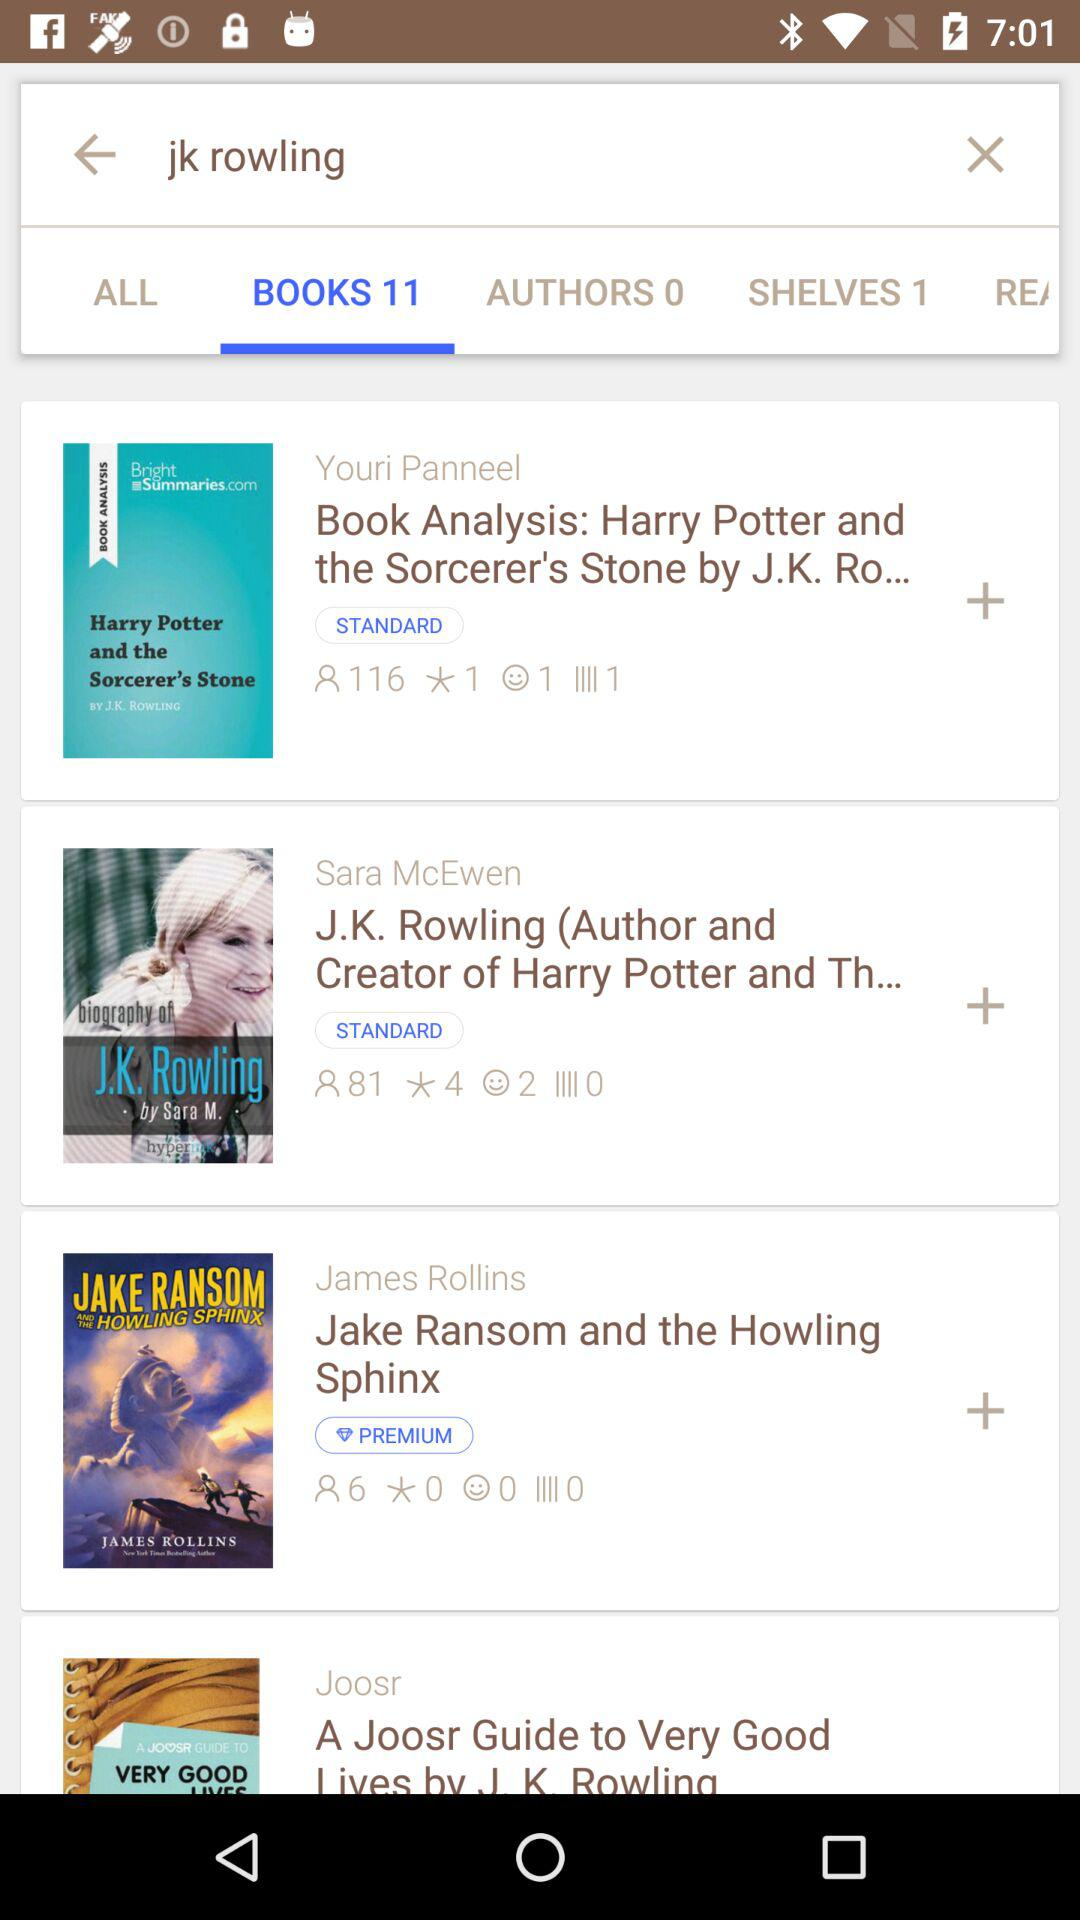How many items are premium?
Answer the question using a single word or phrase. 1 